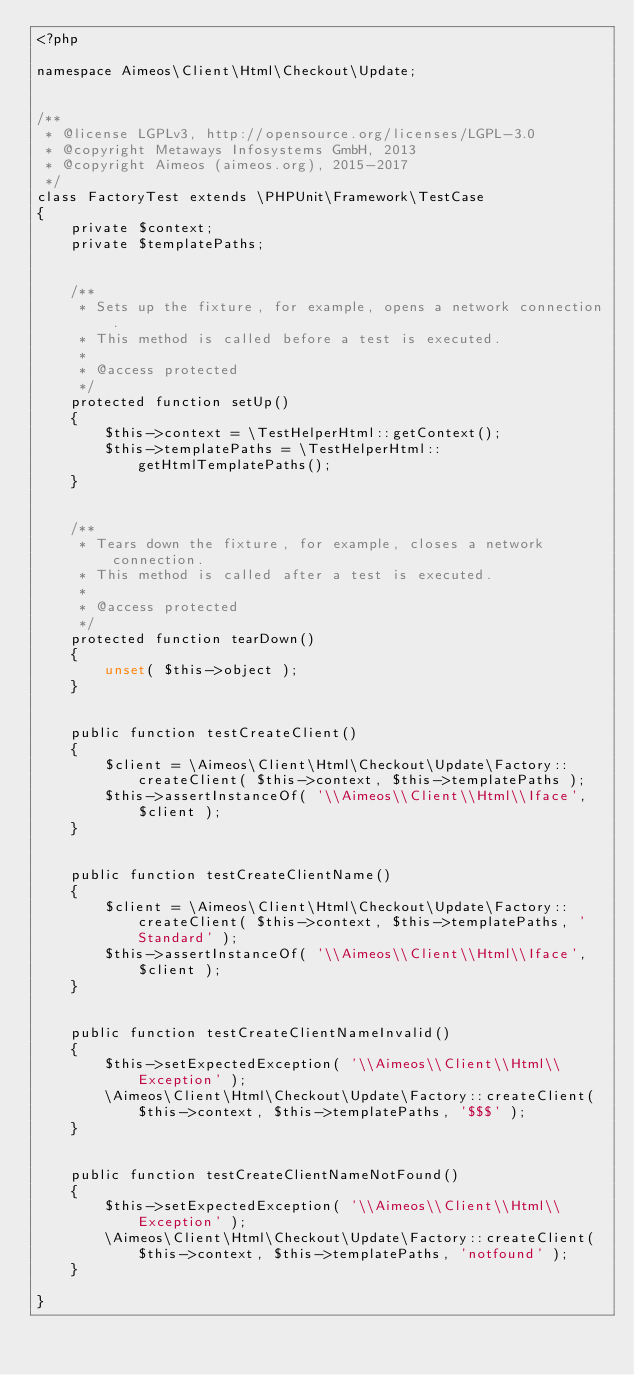<code> <loc_0><loc_0><loc_500><loc_500><_PHP_><?php

namespace Aimeos\Client\Html\Checkout\Update;


/**
 * @license LGPLv3, http://opensource.org/licenses/LGPL-3.0
 * @copyright Metaways Infosystems GmbH, 2013
 * @copyright Aimeos (aimeos.org), 2015-2017
 */
class FactoryTest extends \PHPUnit\Framework\TestCase
{
	private $context;
	private $templatePaths;


	/**
	 * Sets up the fixture, for example, opens a network connection.
	 * This method is called before a test is executed.
	 *
	 * @access protected
	 */
	protected function setUp()
	{
		$this->context = \TestHelperHtml::getContext();
		$this->templatePaths = \TestHelperHtml::getHtmlTemplatePaths();
	}


	/**
	 * Tears down the fixture, for example, closes a network connection.
	 * This method is called after a test is executed.
	 *
	 * @access protected
	 */
	protected function tearDown()
	{
		unset( $this->object );
	}


	public function testCreateClient()
	{
		$client = \Aimeos\Client\Html\Checkout\Update\Factory::createClient( $this->context, $this->templatePaths );
		$this->assertInstanceOf( '\\Aimeos\\Client\\Html\\Iface', $client );
	}


	public function testCreateClientName()
	{
		$client = \Aimeos\Client\Html\Checkout\Update\Factory::createClient( $this->context, $this->templatePaths, 'Standard' );
		$this->assertInstanceOf( '\\Aimeos\\Client\\Html\\Iface', $client );
	}


	public function testCreateClientNameInvalid()
	{
		$this->setExpectedException( '\\Aimeos\\Client\\Html\\Exception' );
		\Aimeos\Client\Html\Checkout\Update\Factory::createClient( $this->context, $this->templatePaths, '$$$' );
	}


	public function testCreateClientNameNotFound()
	{
		$this->setExpectedException( '\\Aimeos\\Client\\Html\\Exception' );
		\Aimeos\Client\Html\Checkout\Update\Factory::createClient( $this->context, $this->templatePaths, 'notfound' );
	}

}
</code> 